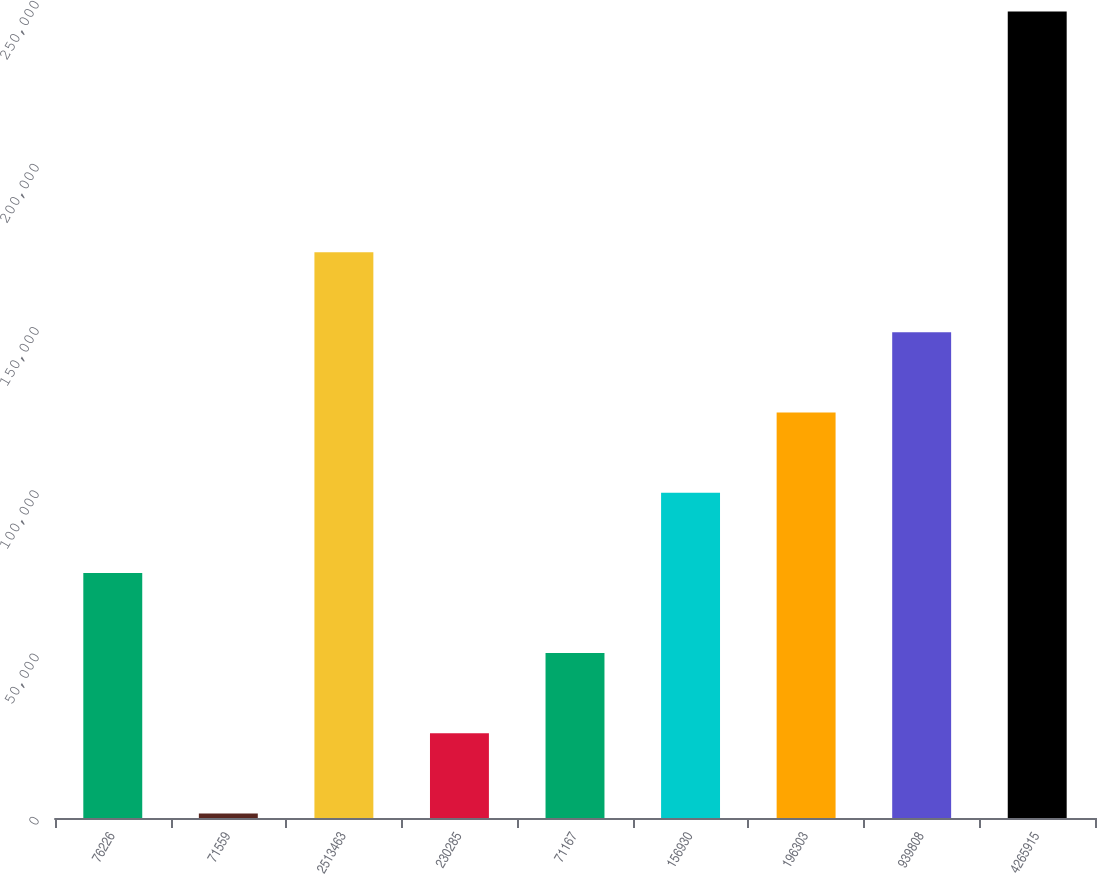Convert chart to OTSL. <chart><loc_0><loc_0><loc_500><loc_500><bar_chart><fcel>76226<fcel>71559<fcel>2513463<fcel>230285<fcel>71167<fcel>156930<fcel>196303<fcel>939808<fcel>4265915<nl><fcel>75094.5<fcel>1395<fcel>173360<fcel>25961.5<fcel>50528<fcel>99661<fcel>124228<fcel>148794<fcel>247060<nl></chart> 